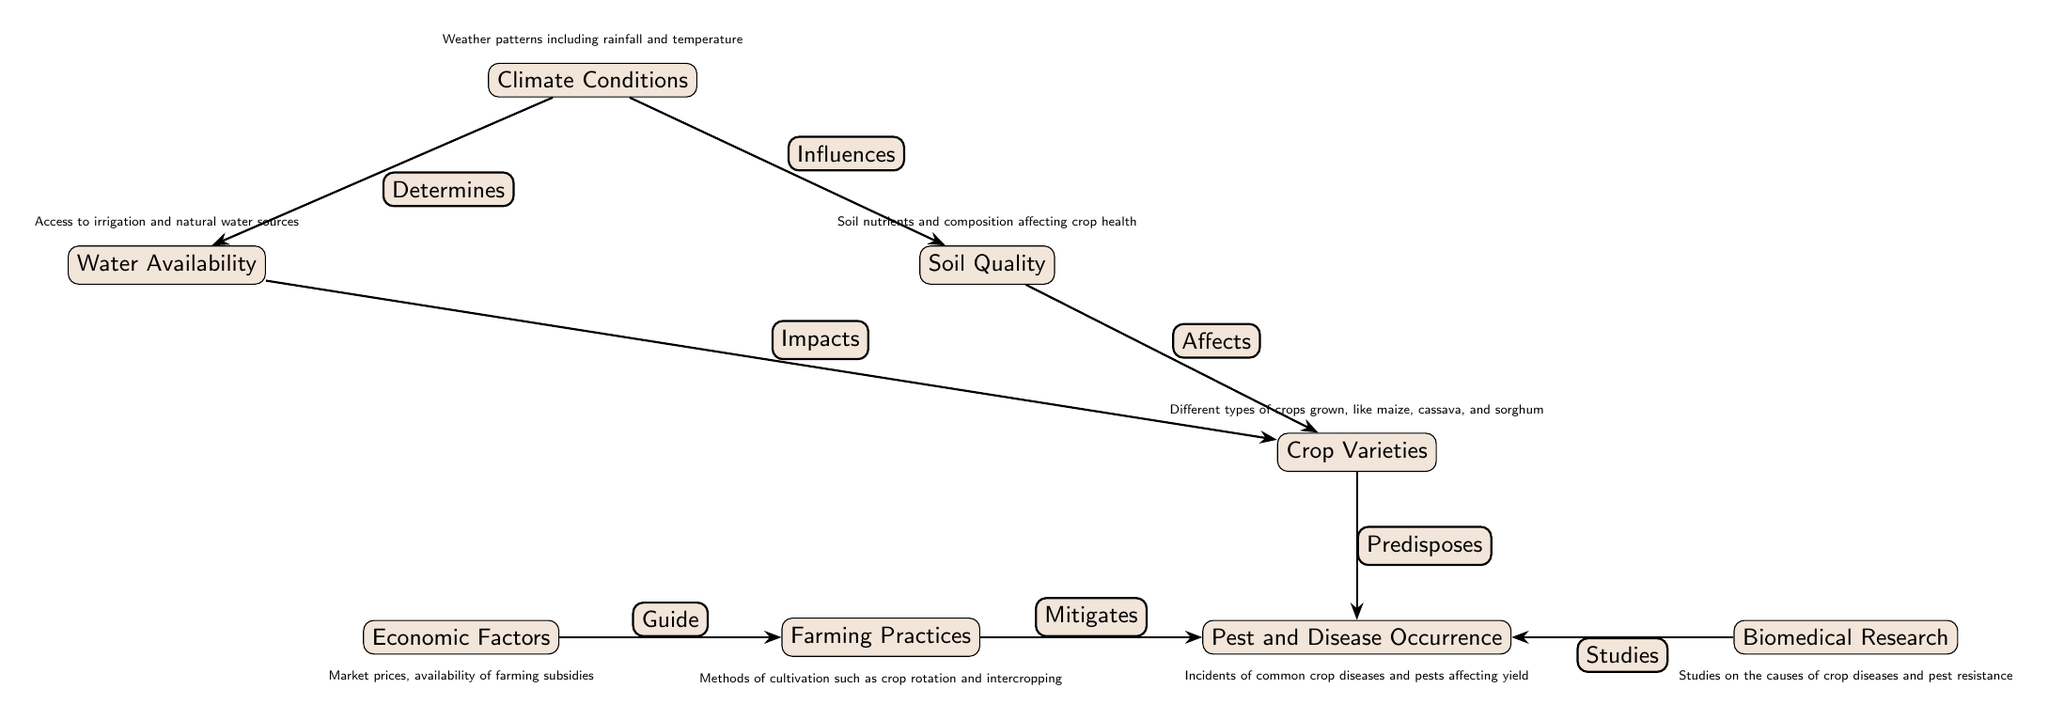What's the central theme of the diagram? The diagram focuses on the factors affecting crop growth and pest occurrence. Each node represents a specific aspect ranging from climate conditions to biomedical research about pests.
Answer: Crop growth and disease patterns How many nodes are in the diagram? By counting the distinct nodes displayed in the diagram, there are eight nodes representing different categories influencing crop health and pest occurrences.
Answer: Eight What do climate conditions influence? The diagram shows an arrow labeled "Influences" leading from climate conditions to soil quality, indicating that climate affects soil conditions for crop growth.
Answer: Soil quality Which node is affected by both soil quality and water availability? The arrows labeled "Affects" from soil quality and "Impacts" from water availability both lead to the crop varieties node, indicating that these two factors impact the types of crops that can be cultivated.
Answer: Crop varieties What relationship exists between farming practices and pest occurrence? The diagram indicates a relationship where farming practices "Mitigates" pest and disease occurrences, suggesting that certain methods of farming can help reduce the impact of pests.
Answer: Mitigates What guides farming practices according to the diagram? The arrow labeled "Guide" from economic factors to farming practices indicates that economic conditions such as market prices influence how farming is conducted.
Answer: Economic factors Which nodes are directly related to pest occurrence? Pest and disease occurrence is directly influenced by crop varieties (which predisposes it) and is also mitigated by farming practices, creating a relationship with these three nodes.
Answer: Crop varieties, Farming practices What is the role of biomedical research in the diagram? The diagram presents biomedical research as studying pest and disease occurrences, showing that research is focused on understanding and developing solutions for pest challenges in crops.
Answer: Studies How does climate conditions impact water availability? The diagram has an arrow labeled "Determines" leading from climate conditions to water availability, suggesting that climatic factors like rainfall influence water resources for agriculture.
Answer: Determines 